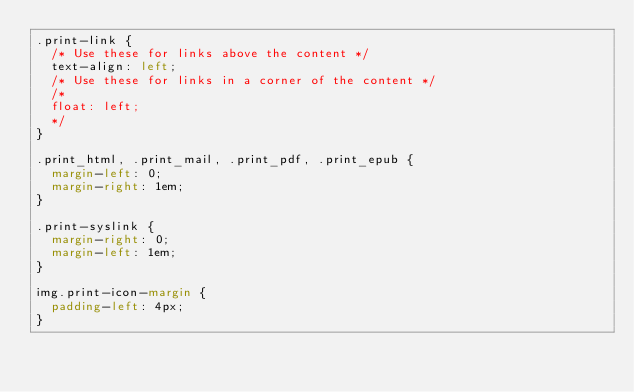Convert code to text. <code><loc_0><loc_0><loc_500><loc_500><_CSS_>.print-link {
  /* Use these for links above the content */
  text-align: left;
  /* Use these for links in a corner of the content */
  /*
  float: left;
  */
}

.print_html, .print_mail, .print_pdf, .print_epub {
  margin-left: 0;
  margin-right: 1em;
}

.print-syslink {
  margin-right: 0;
  margin-left: 1em;
}

img.print-icon-margin {
  padding-left: 4px;
}
</code> 